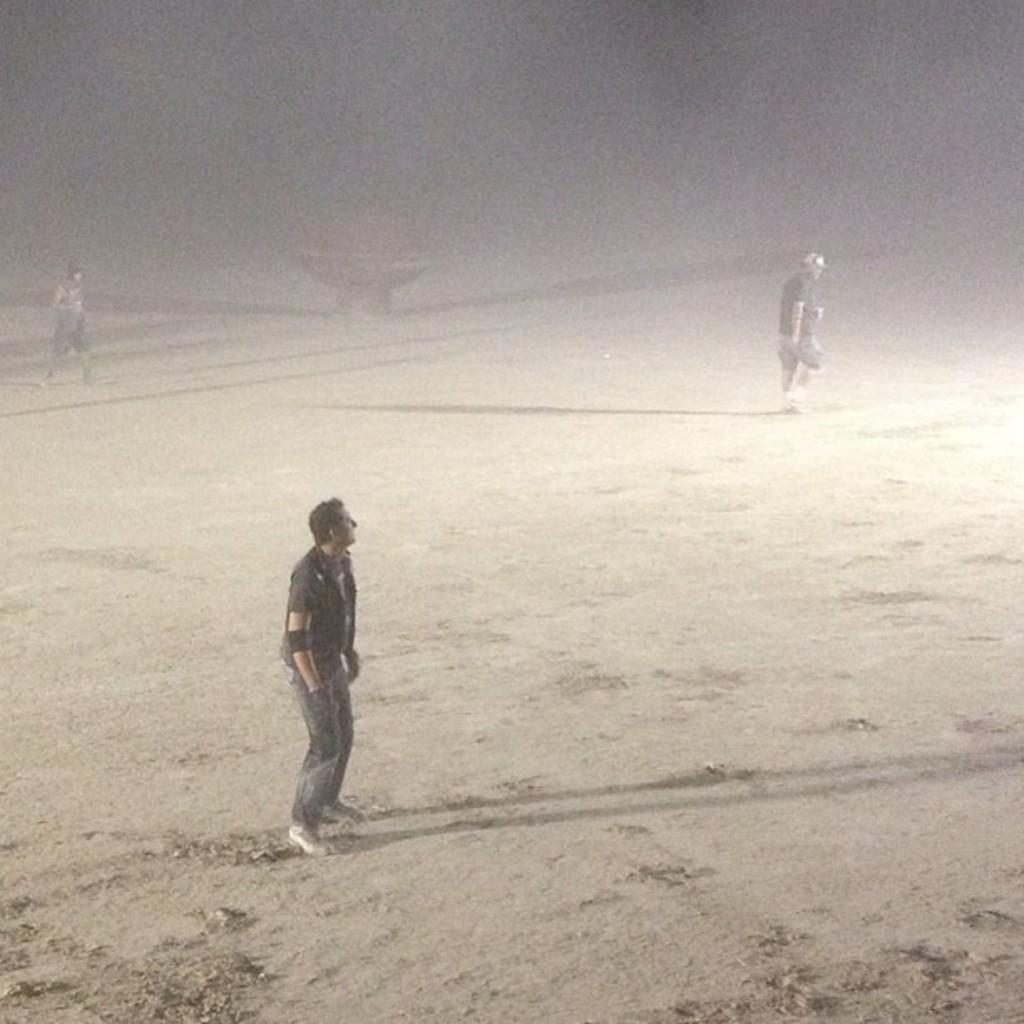Who is present in the image? There are people in the image. What are the people doing in the image? The people are walking. What can be seen beneath the people's feet in the image? The ground is visible in the image. How many sails can be seen in the image? There are no sails present in the image. What type of clothing are the girls wearing in the image? There is no mention of girls in the provided facts, and therefore we cannot answer this question. 